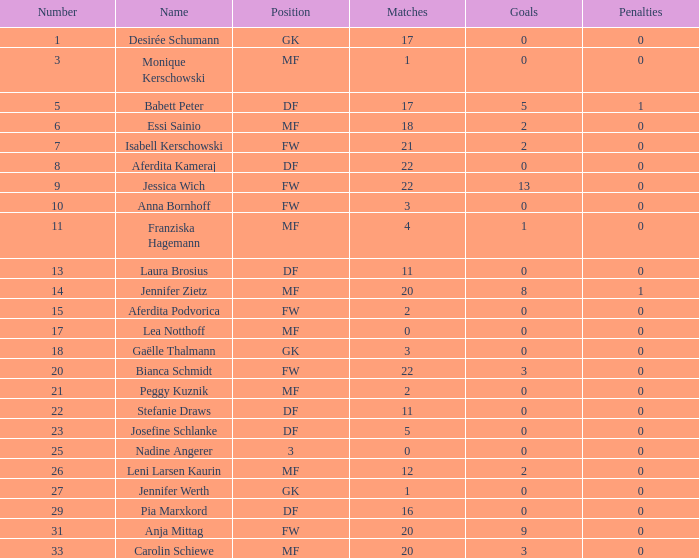What is the average goals for Essi Sainio? 2.0. 